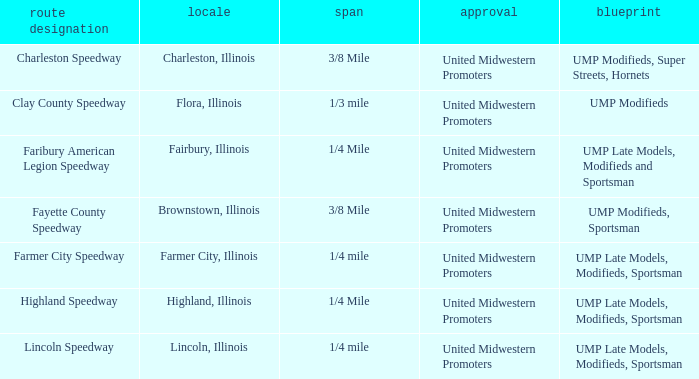What programs were held in charleston, illinois? UMP Modifieds, Super Streets, Hornets. 